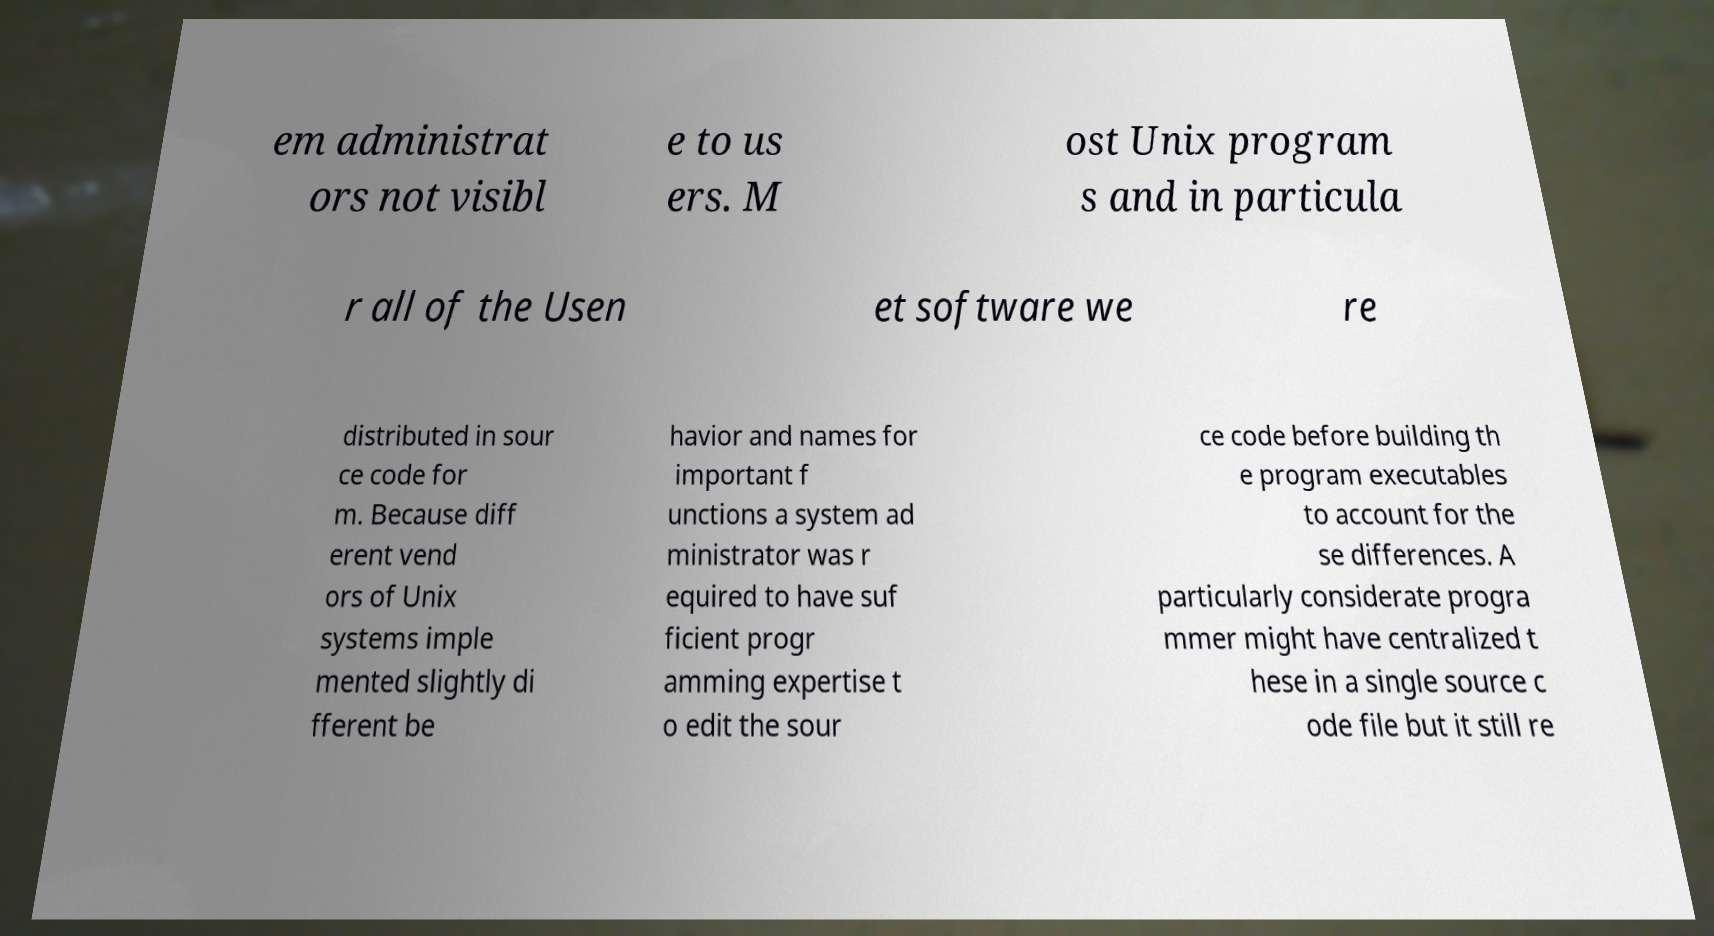Can you accurately transcribe the text from the provided image for me? em administrat ors not visibl e to us ers. M ost Unix program s and in particula r all of the Usen et software we re distributed in sour ce code for m. Because diff erent vend ors of Unix systems imple mented slightly di fferent be havior and names for important f unctions a system ad ministrator was r equired to have suf ficient progr amming expertise t o edit the sour ce code before building th e program executables to account for the se differences. A particularly considerate progra mmer might have centralized t hese in a single source c ode file but it still re 